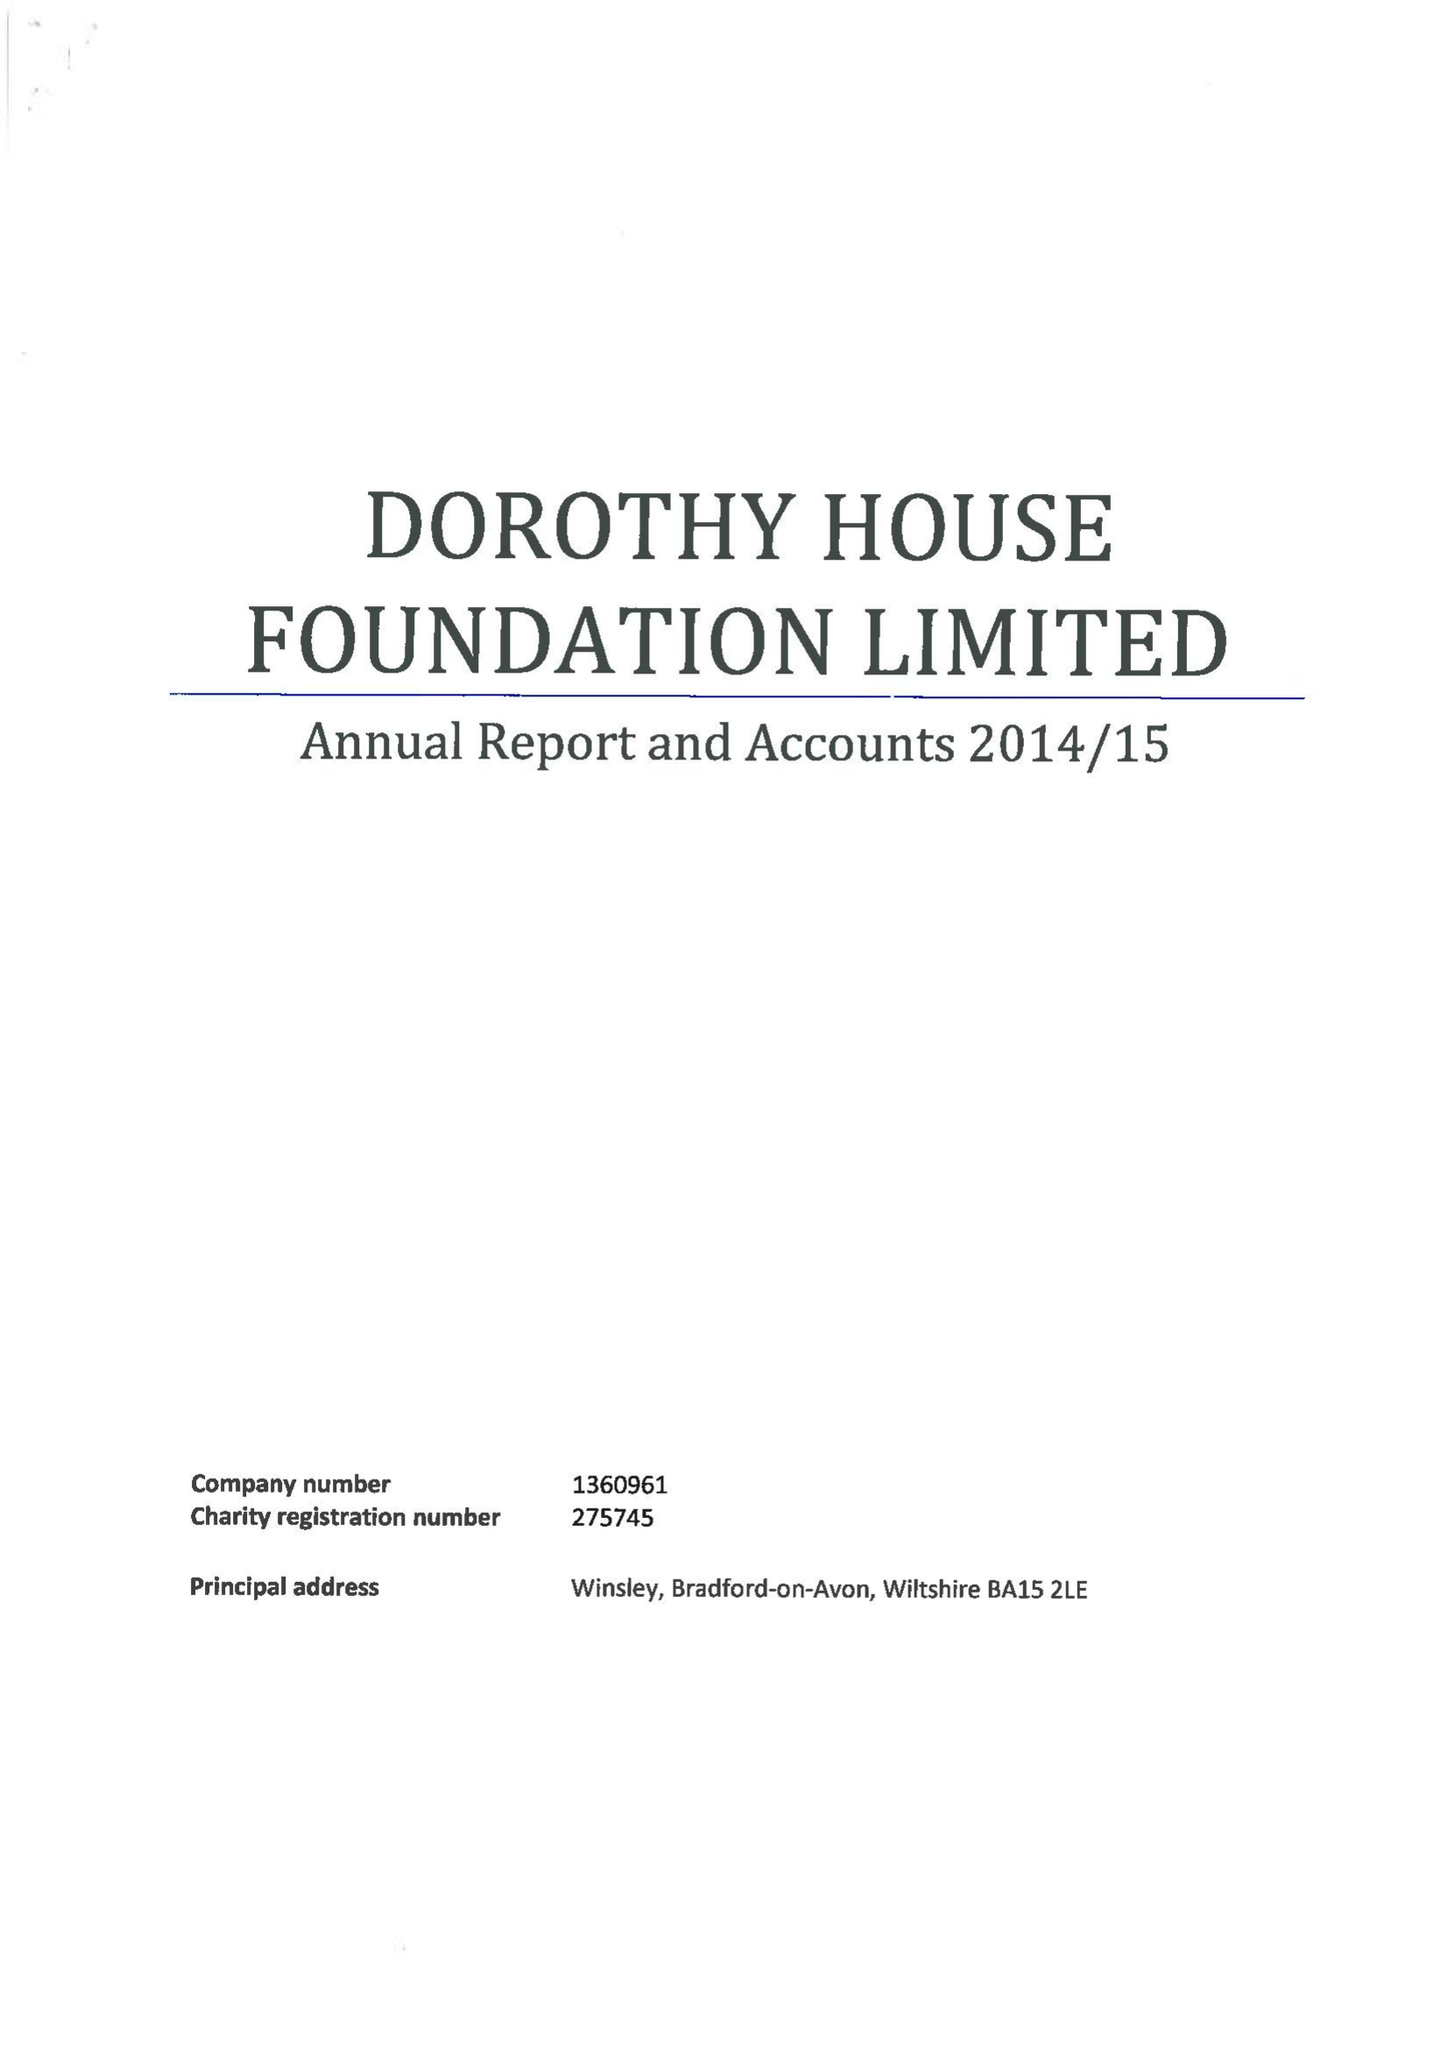What is the value for the address__street_line?
Answer the question using a single word or phrase. None 